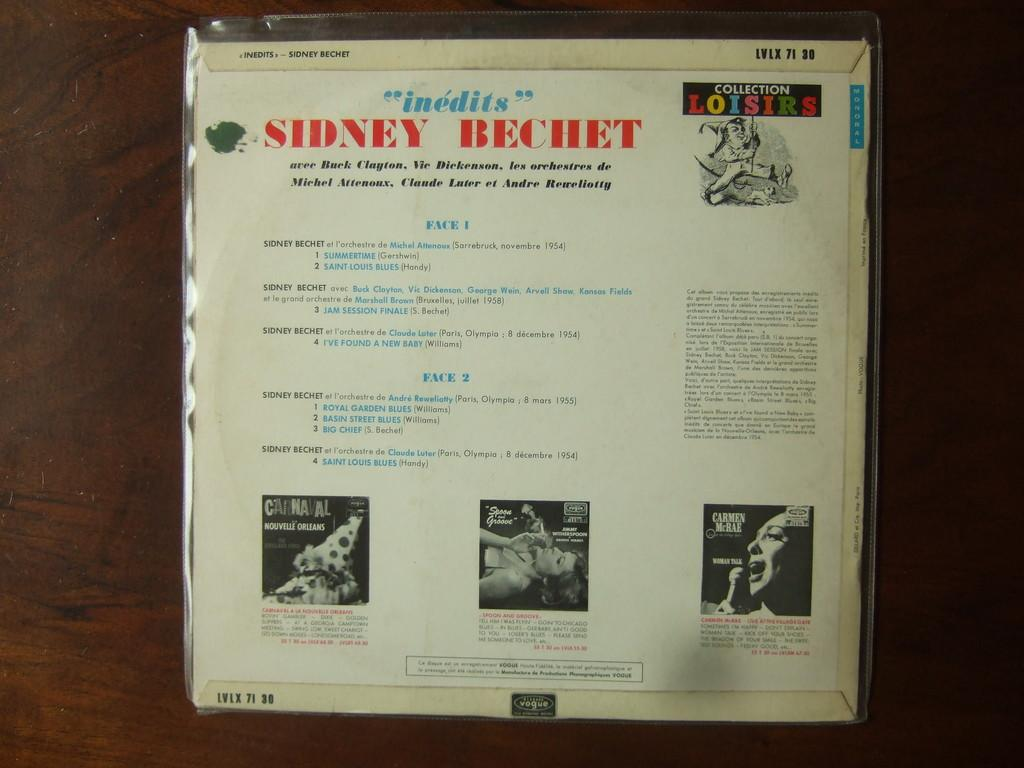<image>
Summarize the visual content of the image. The back of a CD jacket for a Sidney Bechet lists the songs included on the CD. 